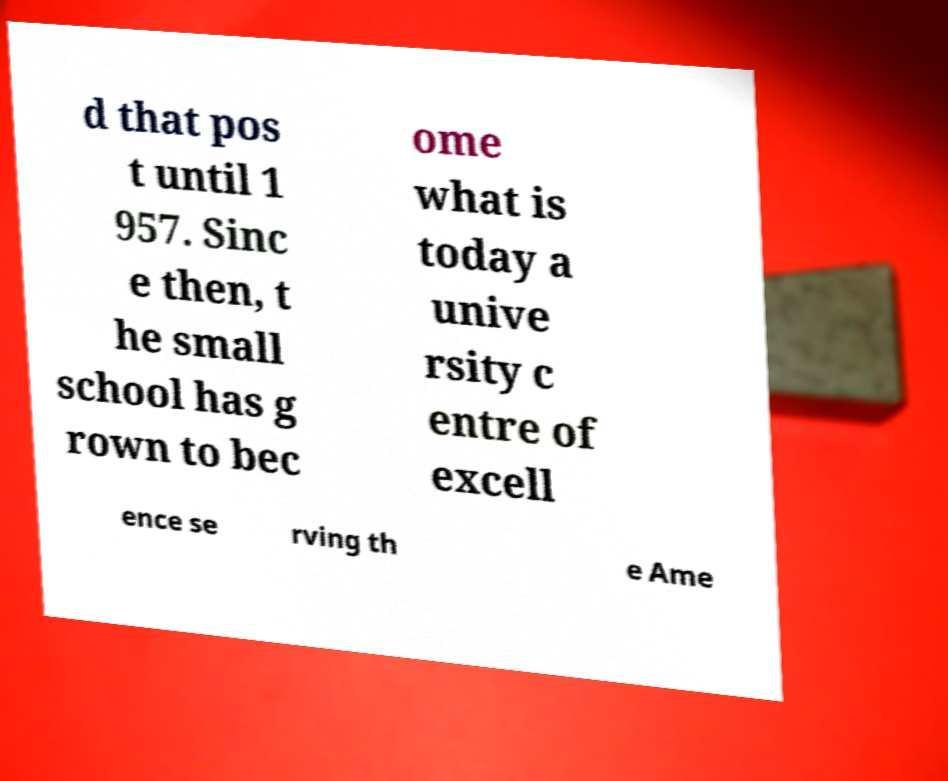Can you accurately transcribe the text from the provided image for me? d that pos t until 1 957. Sinc e then, t he small school has g rown to bec ome what is today a unive rsity c entre of excell ence se rving th e Ame 